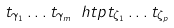<formula> <loc_0><loc_0><loc_500><loc_500>t _ { \gamma _ { 1 } } \dots t _ { \gamma _ { m } } \ h t p t _ { \zeta _ { 1 } } \dots t _ { \zeta _ { p } }</formula> 